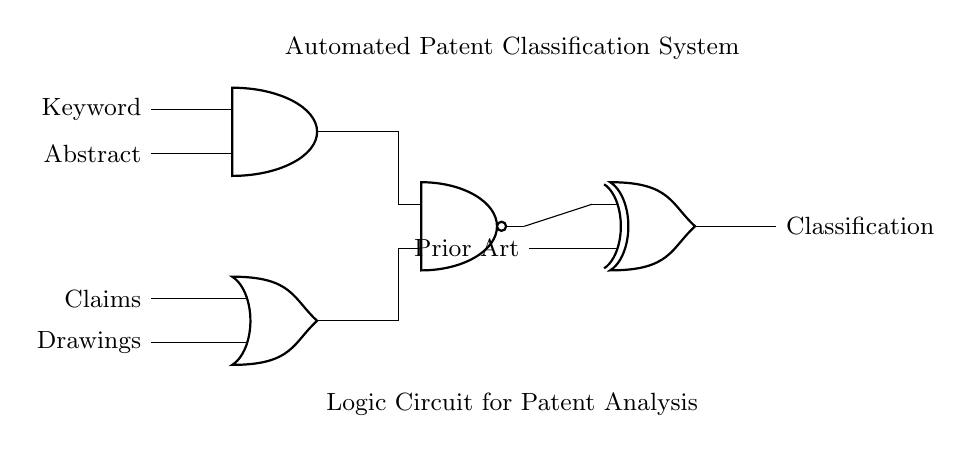What are the inputs for the AND gate? The inputs are labeled 'Keyword' and 'Abstract', which are directly connected to the two input pins of the AND gate in the diagram.
Answer: Keyword, Abstract What type of logic gate is used to combine 'Claims' and 'Drawings'? The 'Claims' and 'Drawings' are input to an OR gate, which is used to perform a logical OR operation to combine the two signals.
Answer: OR gate Which component's output feeds into the XOR gate? The output from the NAND gate feeds into the XOR gate, which is indicated by a connection line leading from the NAND gate to one of the inputs of the XOR gate in the diagram.
Answer: NAND gate What does the 'Classification' output represent? The 'Classification' output is the final result from the XOR gate, indicating the classification result based on the logic inputs to the preceding gates and their processing.
Answer: Classification How many logic gates are present in the circuit? There are four logic gates present: one AND gate, one OR gate, one NAND gate, and one XOR gate, as identified from the circuit diagram.
Answer: Four 